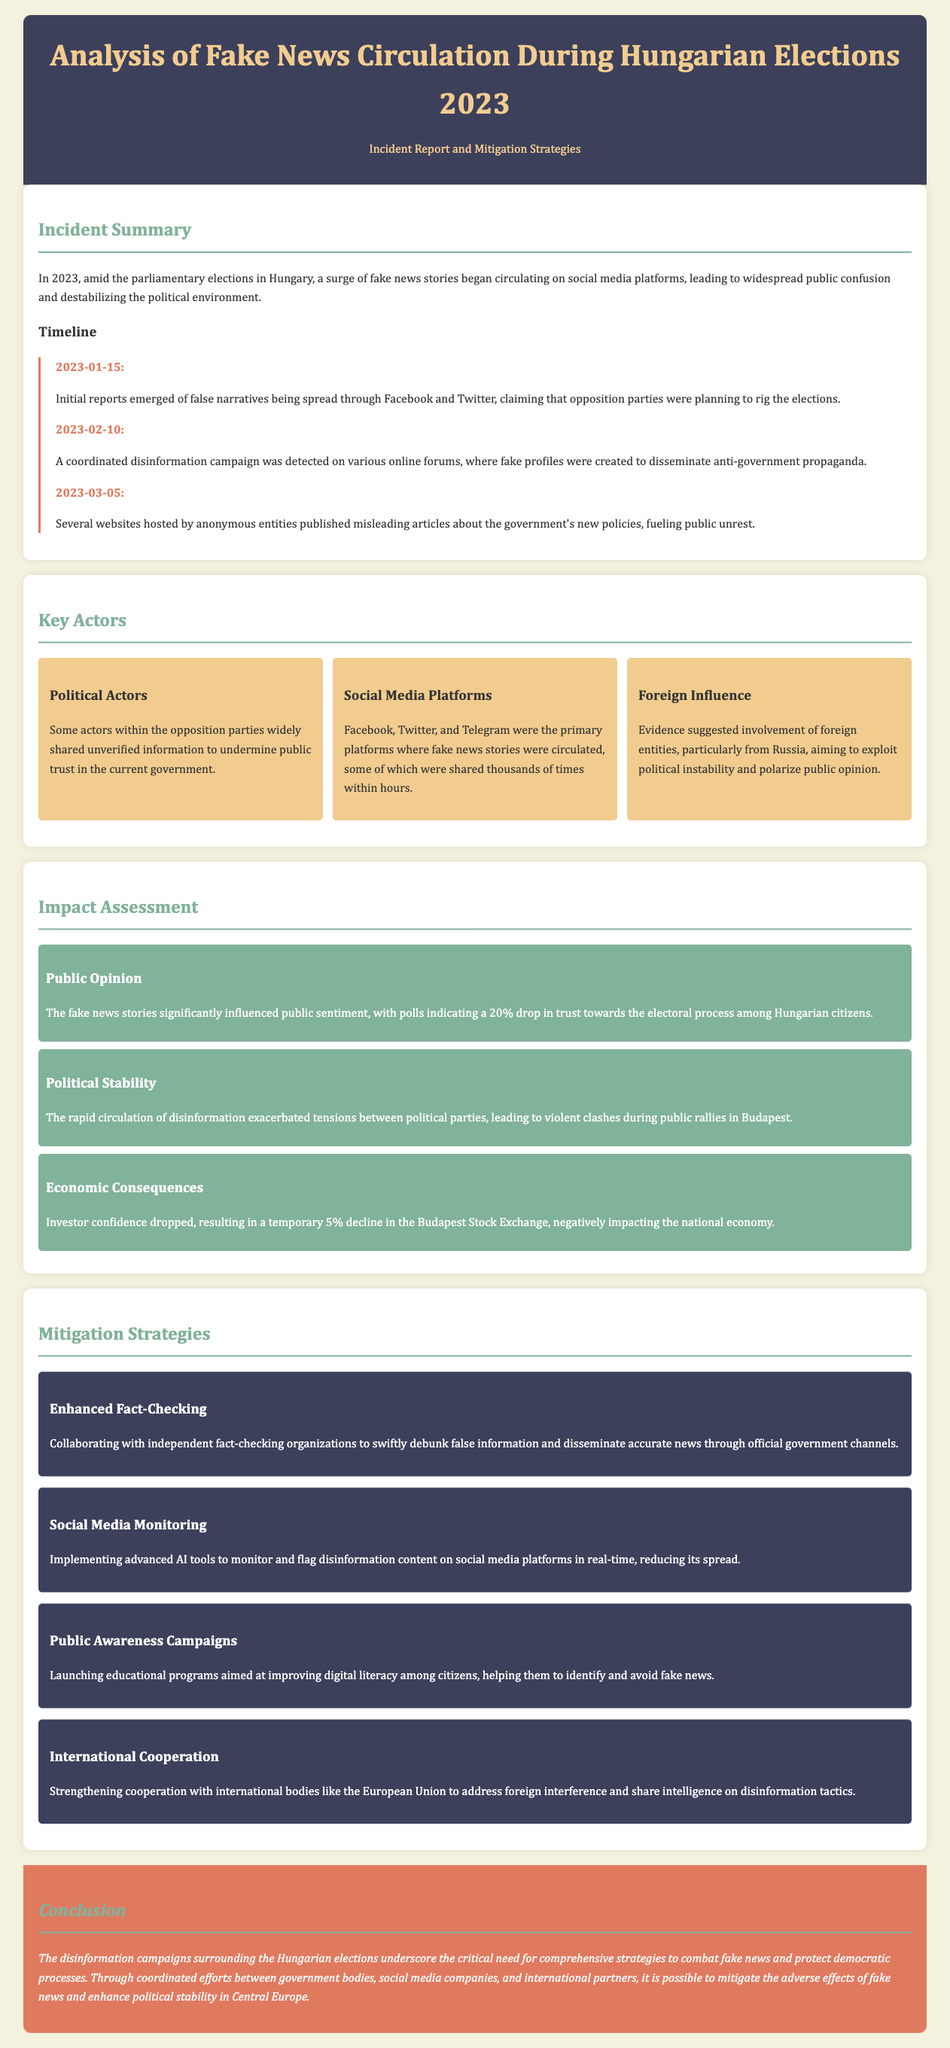What triggered the surge of fake news stories? The surge of fake news stories was triggered by the parliamentary elections in Hungary.
Answer: parliamentary elections in Hungary What date did initial reports of false narratives emerge? Initial reports emerged on the date specified in the timeline section of the document.
Answer: 2023-01-15 Which political party actors primarily spread unverified information? The document states that opposition parties widely shared unverified information.
Answer: opposition parties What was the percentage drop in trust towards the electoral process? The document cites a specific percentage decrease in public trust as indicated by polls.
Answer: 20% What mitigation strategy involves collaboration with independent organizations? The strategy focused on reducing disinformation through careful verification and promotion of accurate news.
Answer: Enhanced Fact-Checking Which social media platforms were highlighted as primary channels for fake news? The document lists the platforms that were most active during the disinformation campaign.
Answer: Facebook, Twitter, and Telegram What was the estimated decline in the Budapest Stock Exchange? This refers to the negative economic consequence detailed in the impact assessment section.
Answer: 5% What institution is suggested to strengthen international cooperation against disinformation? The document mentions a specific international organization aimed at helping with disinformation tactics.
Answer: European Union What was observed in public tensions as a result of fake news circulation? The document describes the consequence of escalating tensions between political factions leading to incidents.
Answer: violent clashes 